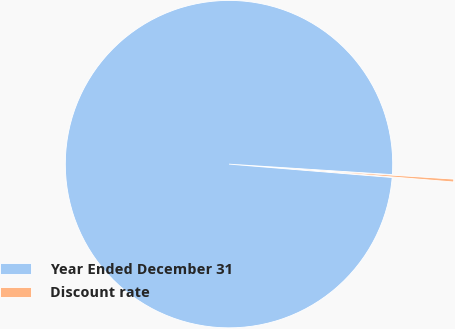Convert chart. <chart><loc_0><loc_0><loc_500><loc_500><pie_chart><fcel>Year Ended December 31<fcel>Discount rate<nl><fcel>99.72%<fcel>0.28%<nl></chart> 